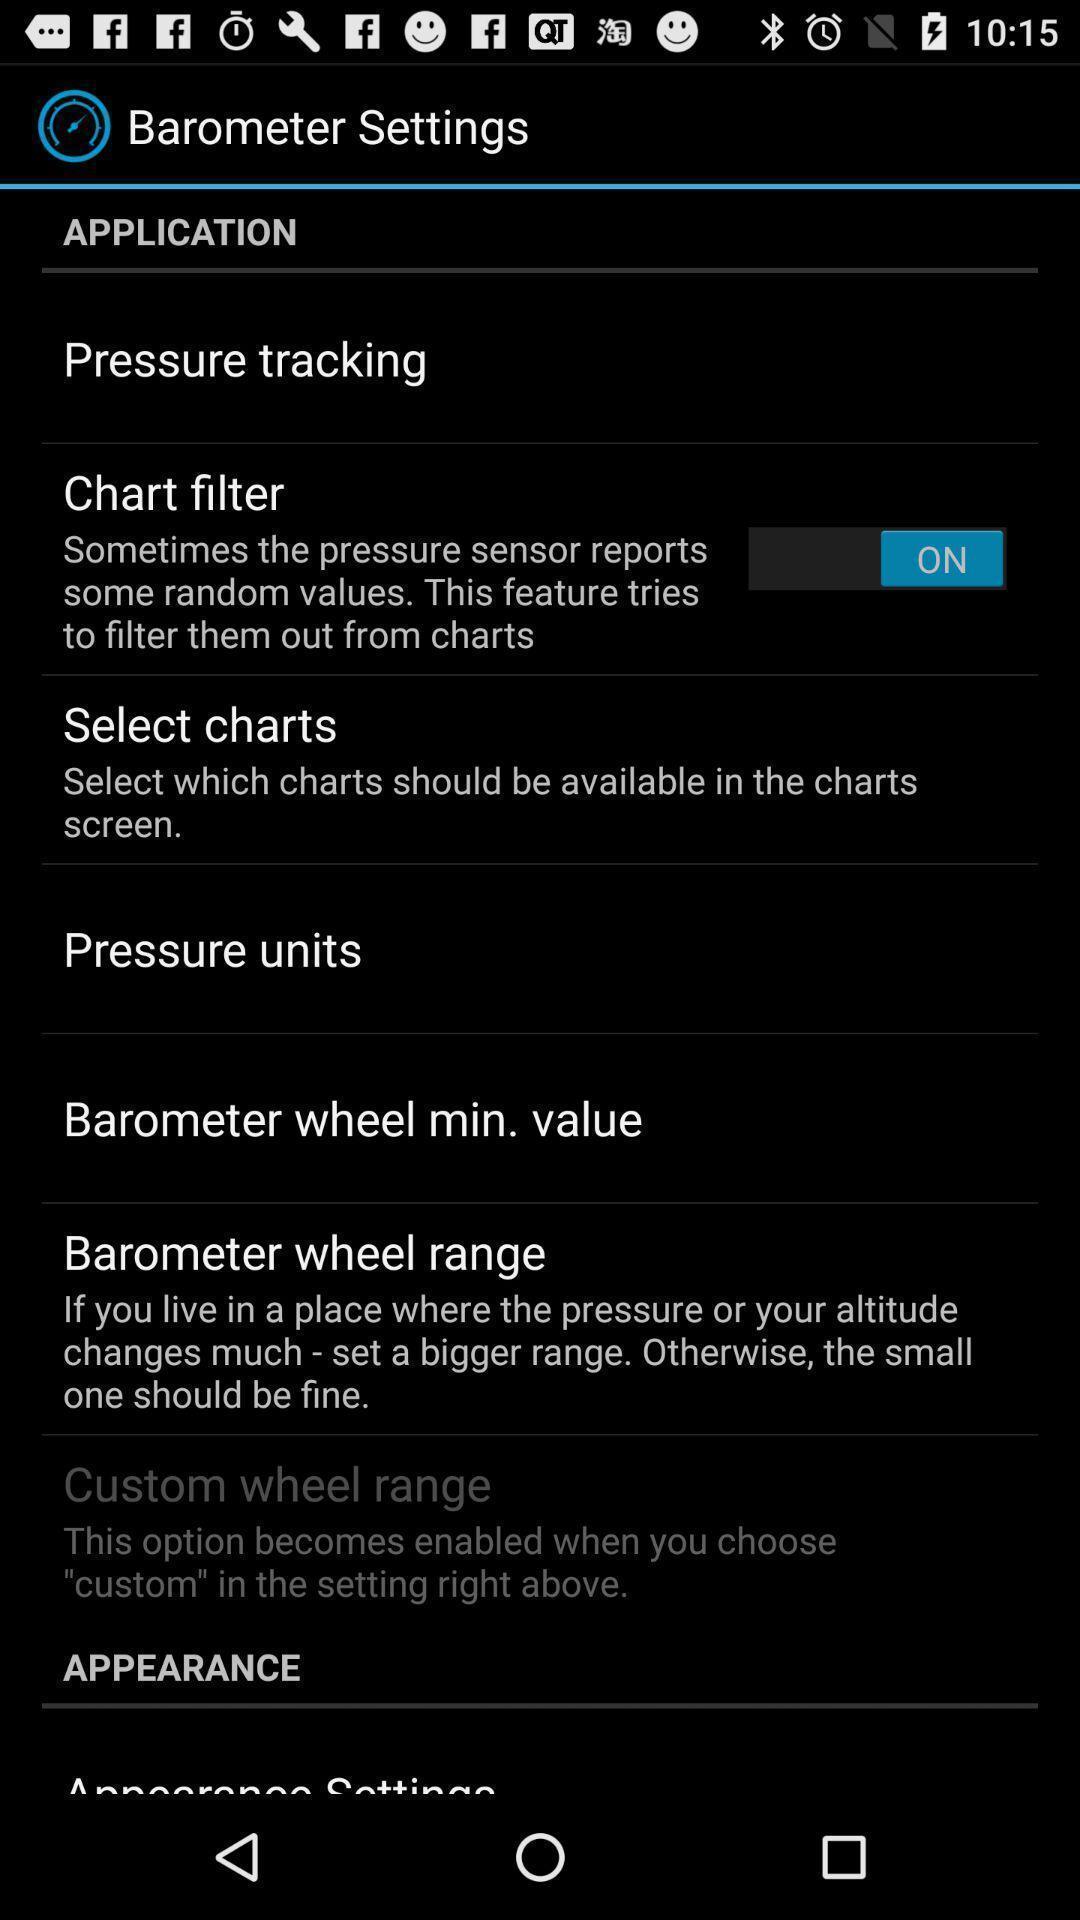Describe the content in this image. Screen shows settings page. 